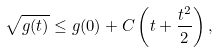<formula> <loc_0><loc_0><loc_500><loc_500>\sqrt { g ( t ) } \leq g ( 0 ) + C \left ( t + \frac { t ^ { 2 } } { 2 } \right ) ,</formula> 